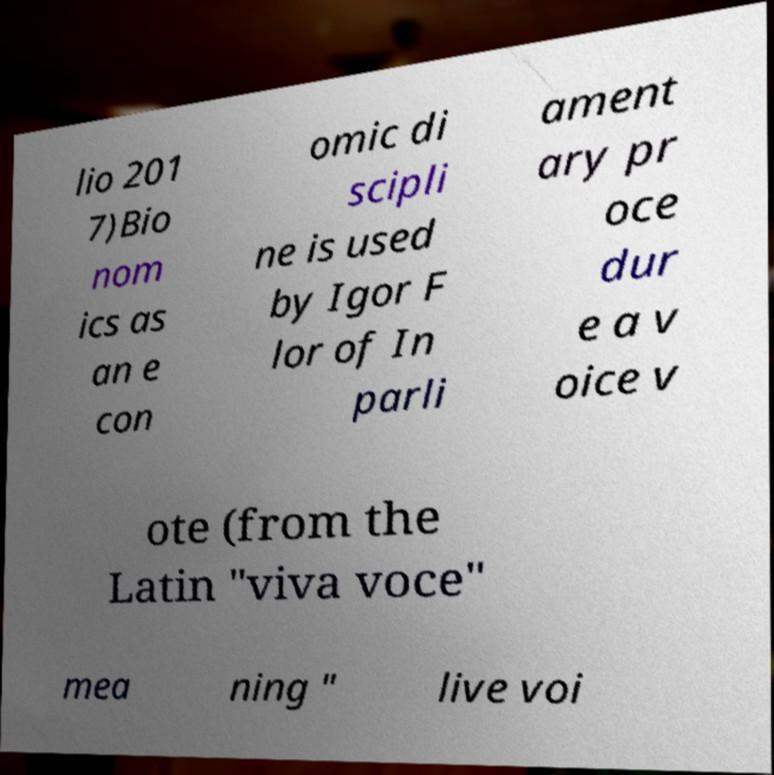Please read and relay the text visible in this image. What does it say? lio 201 7)Bio nom ics as an e con omic di scipli ne is used by Igor F lor of In parli ament ary pr oce dur e a v oice v ote (from the Latin "viva voce" mea ning " live voi 